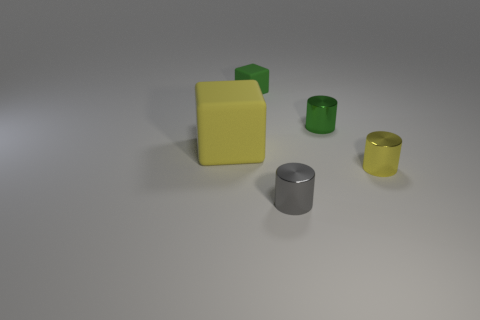There is a small gray metallic thing; how many yellow things are right of it?
Your response must be concise. 1. How many tiny objects are both behind the yellow matte object and in front of the yellow cylinder?
Ensure brevity in your answer.  0. What is the shape of the yellow object that is the same material as the gray cylinder?
Your response must be concise. Cylinder. There is a cube that is on the right side of the large yellow rubber object; is it the same size as the matte thing that is on the left side of the tiny green matte cube?
Give a very brief answer. No. What is the color of the object that is left of the small cube?
Ensure brevity in your answer.  Yellow. What material is the thing that is to the left of the cube that is to the right of the large object?
Provide a succinct answer. Rubber. The small gray shiny object has what shape?
Offer a terse response. Cylinder. There is a tiny gray thing that is the same shape as the yellow shiny thing; what is it made of?
Provide a succinct answer. Metal. How many yellow metallic objects are the same size as the green rubber cube?
Make the answer very short. 1. Is there a small matte thing left of the tiny object behind the small green cylinder?
Your answer should be very brief. No. 